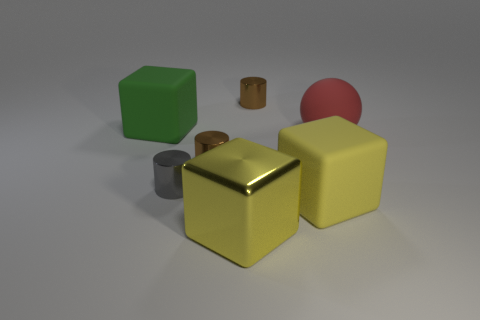Subtract all small brown shiny cylinders. How many cylinders are left? 1 Subtract all purple cylinders. How many yellow cubes are left? 2 Add 1 large yellow cubes. How many objects exist? 8 Subtract 1 spheres. How many spheres are left? 0 Subtract all spheres. How many objects are left? 6 Subtract all gray cubes. Subtract all gray spheres. How many cubes are left? 3 Subtract all balls. Subtract all small cylinders. How many objects are left? 3 Add 4 cubes. How many cubes are left? 7 Add 5 large spheres. How many large spheres exist? 6 Subtract 0 green cylinders. How many objects are left? 7 